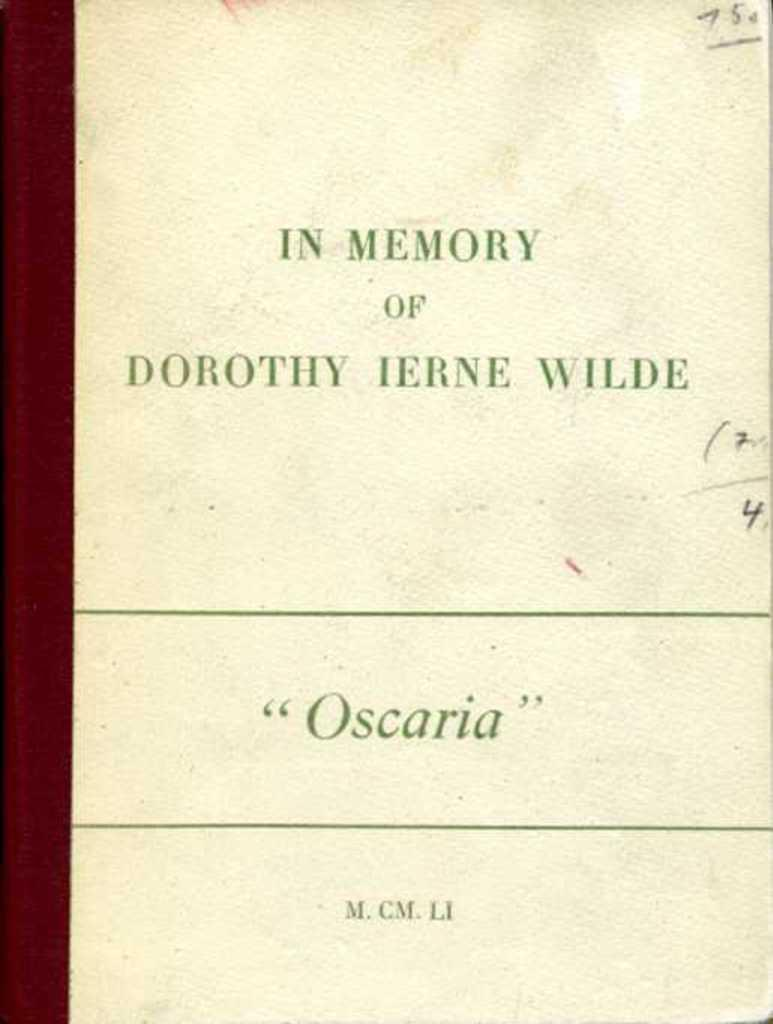<image>
Relay a brief, clear account of the picture shown. A page titled In Memory of Dorothy Ierne Wilde rests on a table. 